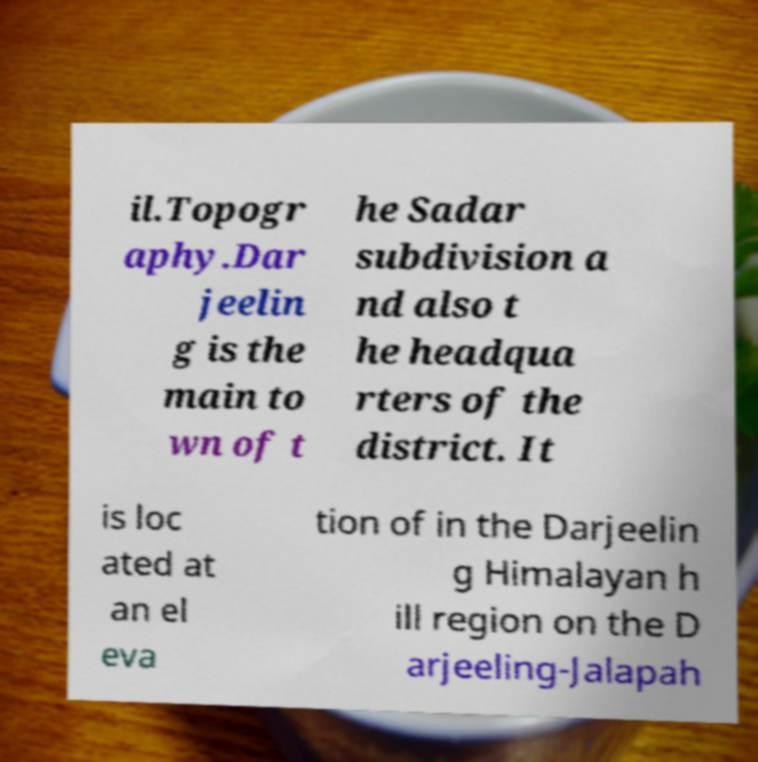For documentation purposes, I need the text within this image transcribed. Could you provide that? il.Topogr aphy.Dar jeelin g is the main to wn of t he Sadar subdivision a nd also t he headqua rters of the district. It is loc ated at an el eva tion of in the Darjeelin g Himalayan h ill region on the D arjeeling-Jalapah 